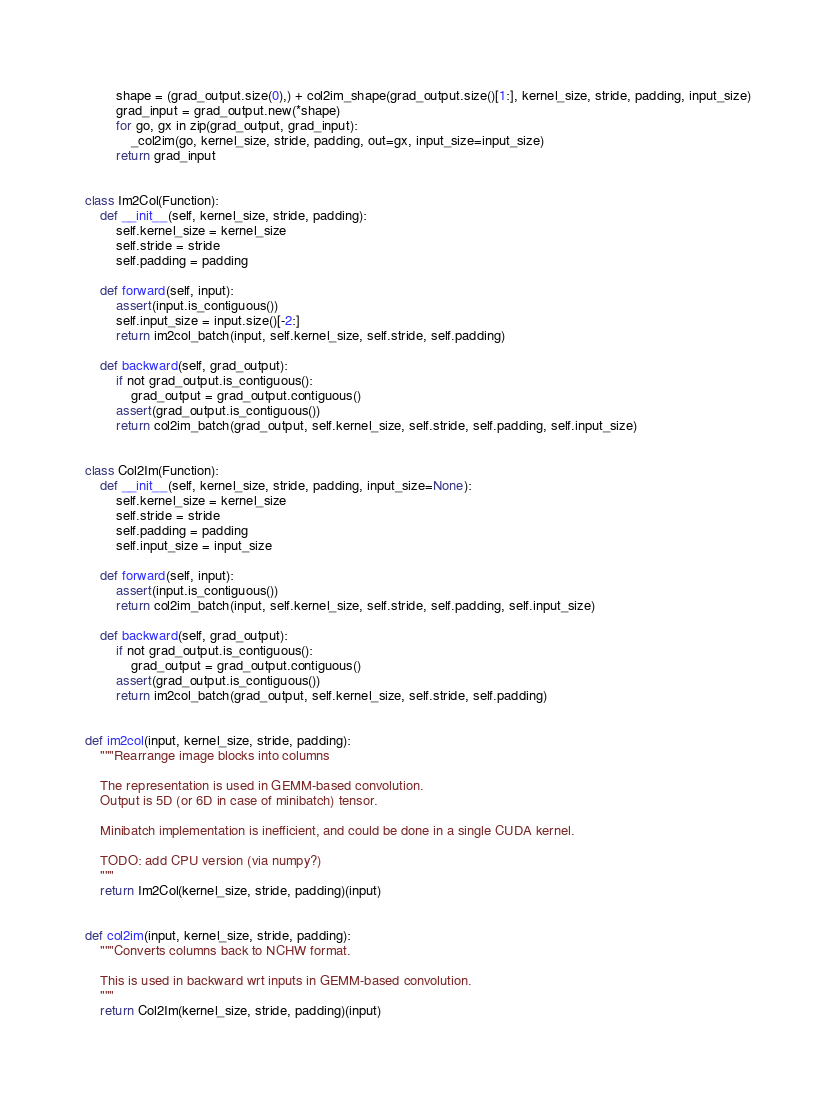<code> <loc_0><loc_0><loc_500><loc_500><_Python_>        shape = (grad_output.size(0),) + col2im_shape(grad_output.size()[1:], kernel_size, stride, padding, input_size)
        grad_input = grad_output.new(*shape)
        for go, gx in zip(grad_output, grad_input):
            _col2im(go, kernel_size, stride, padding, out=gx, input_size=input_size)
        return grad_input


class Im2Col(Function):
    def __init__(self, kernel_size, stride, padding):
        self.kernel_size = kernel_size
        self.stride = stride
        self.padding = padding

    def forward(self, input):
        assert(input.is_contiguous())
        self.input_size = input.size()[-2:]
        return im2col_batch(input, self.kernel_size, self.stride, self.padding)

    def backward(self, grad_output):
        if not grad_output.is_contiguous():
            grad_output = grad_output.contiguous()
        assert(grad_output.is_contiguous())
        return col2im_batch(grad_output, self.kernel_size, self.stride, self.padding, self.input_size)


class Col2Im(Function):
    def __init__(self, kernel_size, stride, padding, input_size=None):
        self.kernel_size = kernel_size
        self.stride = stride
        self.padding = padding
        self.input_size = input_size

    def forward(self, input):
        assert(input.is_contiguous())
        return col2im_batch(input, self.kernel_size, self.stride, self.padding, self.input_size)

    def backward(self, grad_output):
        if not grad_output.is_contiguous():
            grad_output = grad_output.contiguous()
        assert(grad_output.is_contiguous())        
        return im2col_batch(grad_output, self.kernel_size, self.stride, self.padding)


def im2col(input, kernel_size, stride, padding):
    """Rearrange image blocks into columns

    The representation is used in GEMM-based convolution.
    Output is 5D (or 6D in case of minibatch) tensor.

    Minibatch implementation is inefficient, and could be done in a single CUDA kernel.

    TODO: add CPU version (via numpy?)
    """
    return Im2Col(kernel_size, stride, padding)(input)


def col2im(input, kernel_size, stride, padding):
    """Converts columns back to NCHW format.

    This is used in backward wrt inputs in GEMM-based convolution.
    """
    return Col2Im(kernel_size, stride, padding)(input)
</code> 